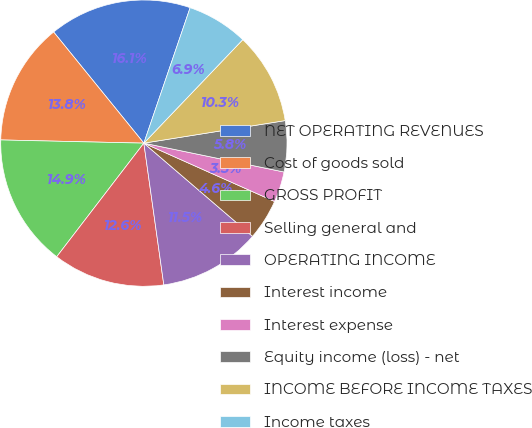Convert chart. <chart><loc_0><loc_0><loc_500><loc_500><pie_chart><fcel>NET OPERATING REVENUES<fcel>Cost of goods sold<fcel>GROSS PROFIT<fcel>Selling general and<fcel>OPERATING INCOME<fcel>Interest income<fcel>Interest expense<fcel>Equity income (loss) - net<fcel>INCOME BEFORE INCOME TAXES<fcel>Income taxes<nl><fcel>16.09%<fcel>13.79%<fcel>14.94%<fcel>12.64%<fcel>11.49%<fcel>4.6%<fcel>3.45%<fcel>5.75%<fcel>10.34%<fcel>6.9%<nl></chart> 